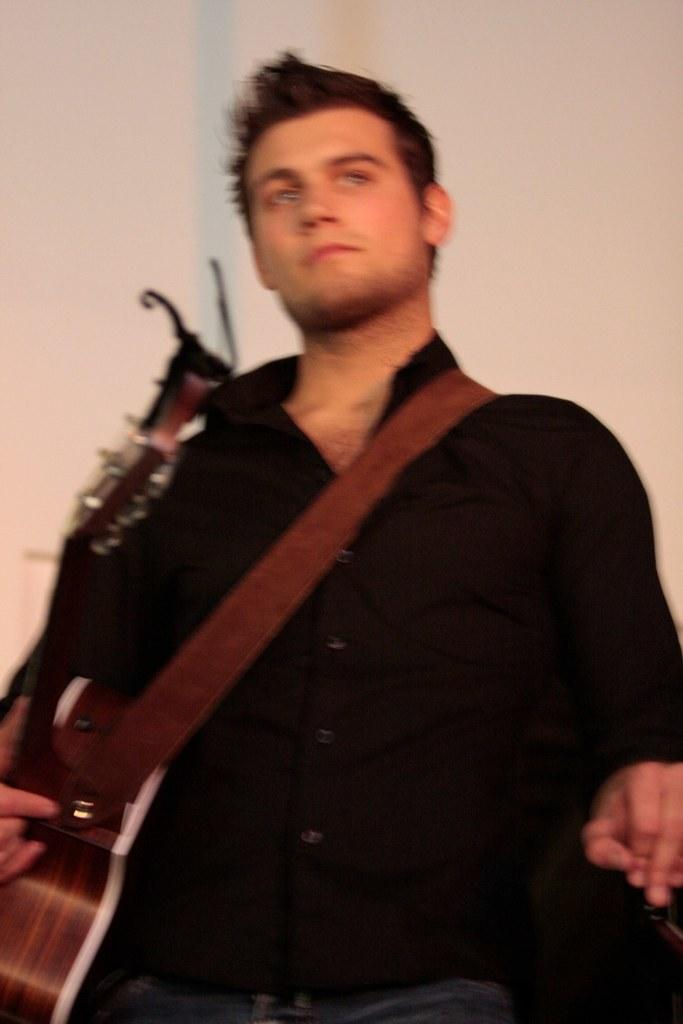What is the person in the image wearing? The person is wearing a black shirt with colorful elements. What is the person holding in the image? The person is holding a guitar. What type of button can be seen on the shirt in the image? There is no button visible on the shirt in the image. What kind of jewel is adorning the guitar in the image? There is no jewel present on the guitar in the image. 